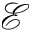<formula> <loc_0><loc_0><loc_500><loc_500>\mathcal { E }</formula> 